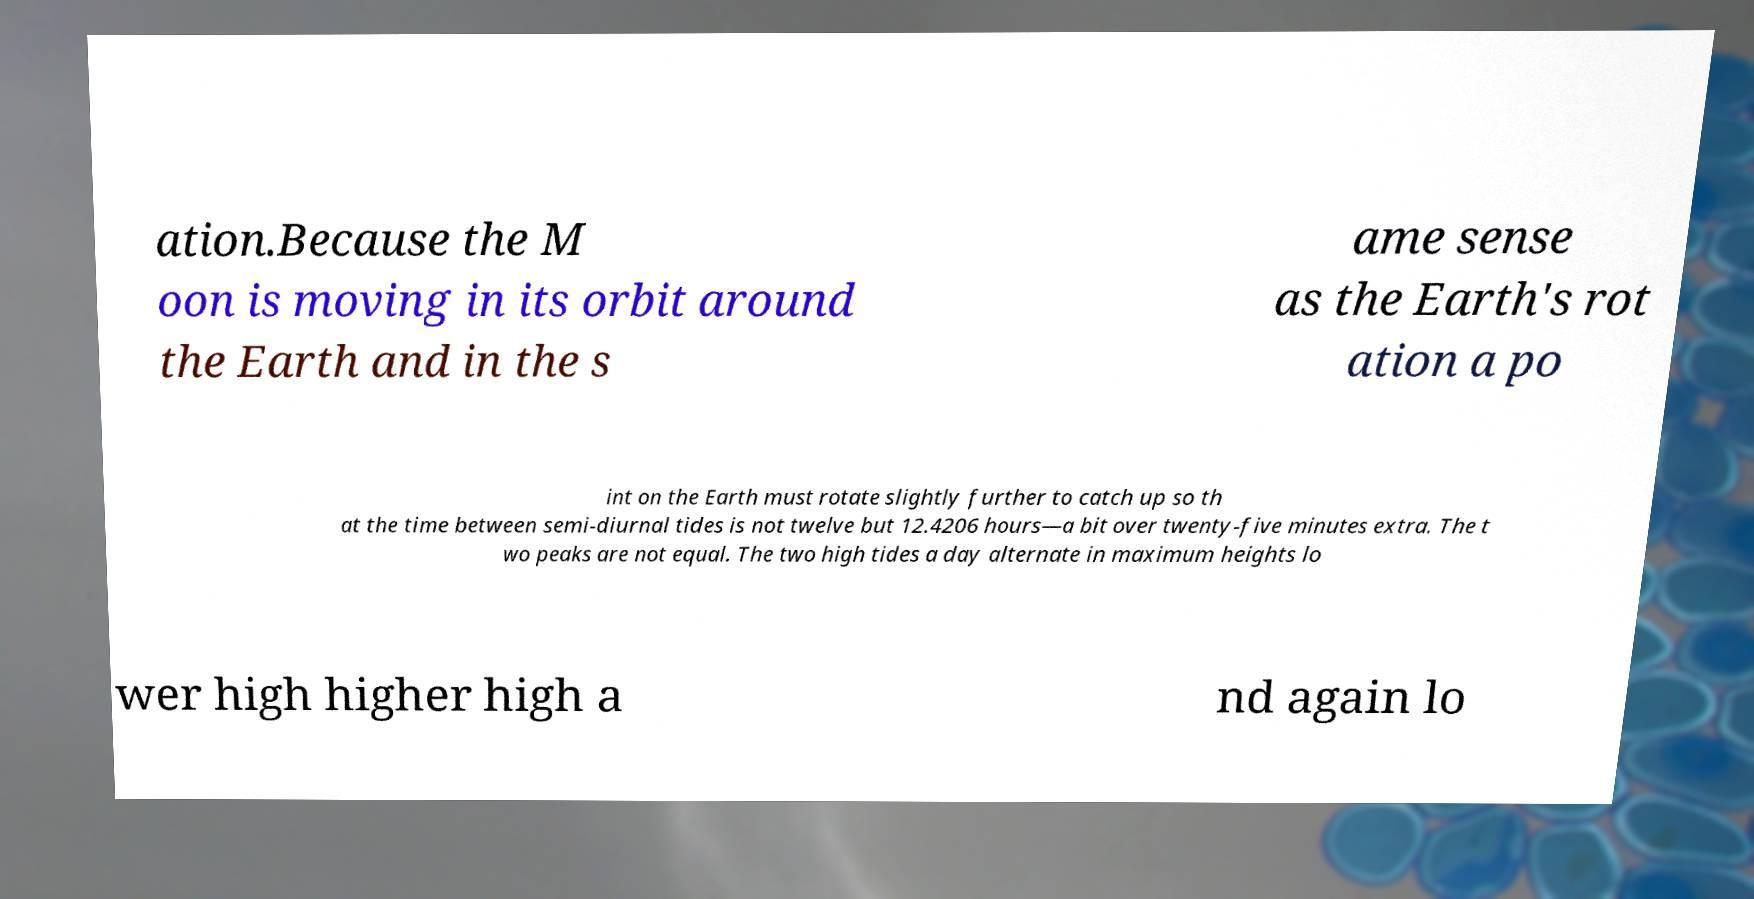Please identify and transcribe the text found in this image. ation.Because the M oon is moving in its orbit around the Earth and in the s ame sense as the Earth's rot ation a po int on the Earth must rotate slightly further to catch up so th at the time between semi-diurnal tides is not twelve but 12.4206 hours—a bit over twenty-five minutes extra. The t wo peaks are not equal. The two high tides a day alternate in maximum heights lo wer high higher high a nd again lo 